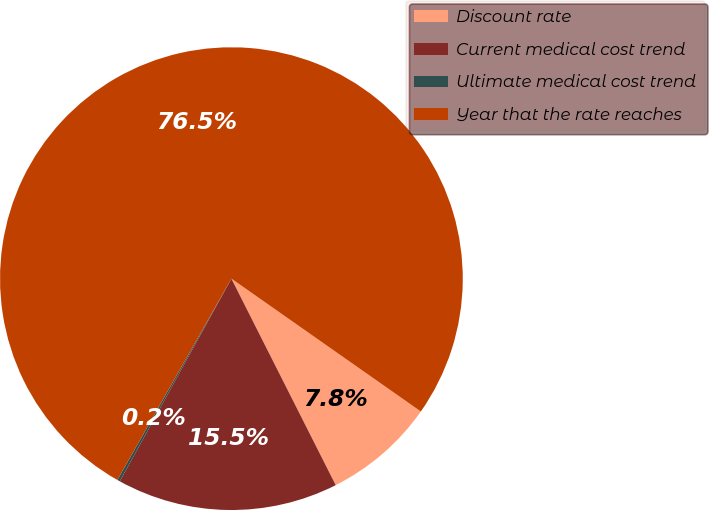Convert chart. <chart><loc_0><loc_0><loc_500><loc_500><pie_chart><fcel>Discount rate<fcel>Current medical cost trend<fcel>Ultimate medical cost trend<fcel>Year that the rate reaches<nl><fcel>7.82%<fcel>15.46%<fcel>0.19%<fcel>76.53%<nl></chart> 